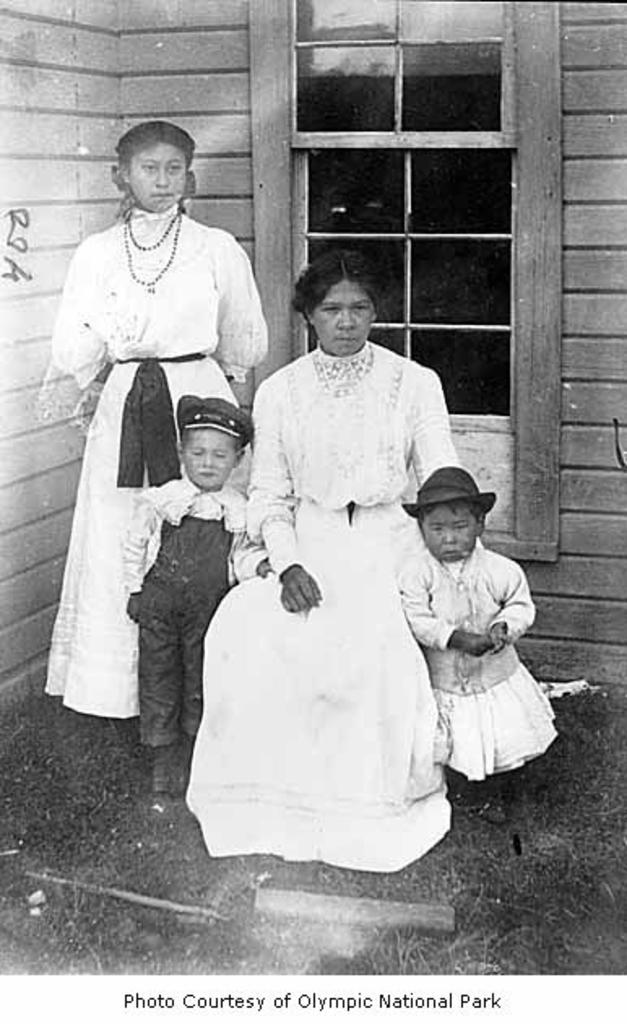How many people are in the old image? There are two women and a small kid in the old image. What are the women and the kid doing in the image? The women and the kid are sitting in front. What can be seen in the background of the image? There is a glass window and a wooden panel wall in the background. What type of owl can be seen perched on the wooden panel wall in the image? There is no owl present in the image; it only features two women, a small kid, a glass window, and a wooden panel wall. What sound do the bells make in the image? There are no bells present in the image, so it is not possible to determine the sound they might make. 